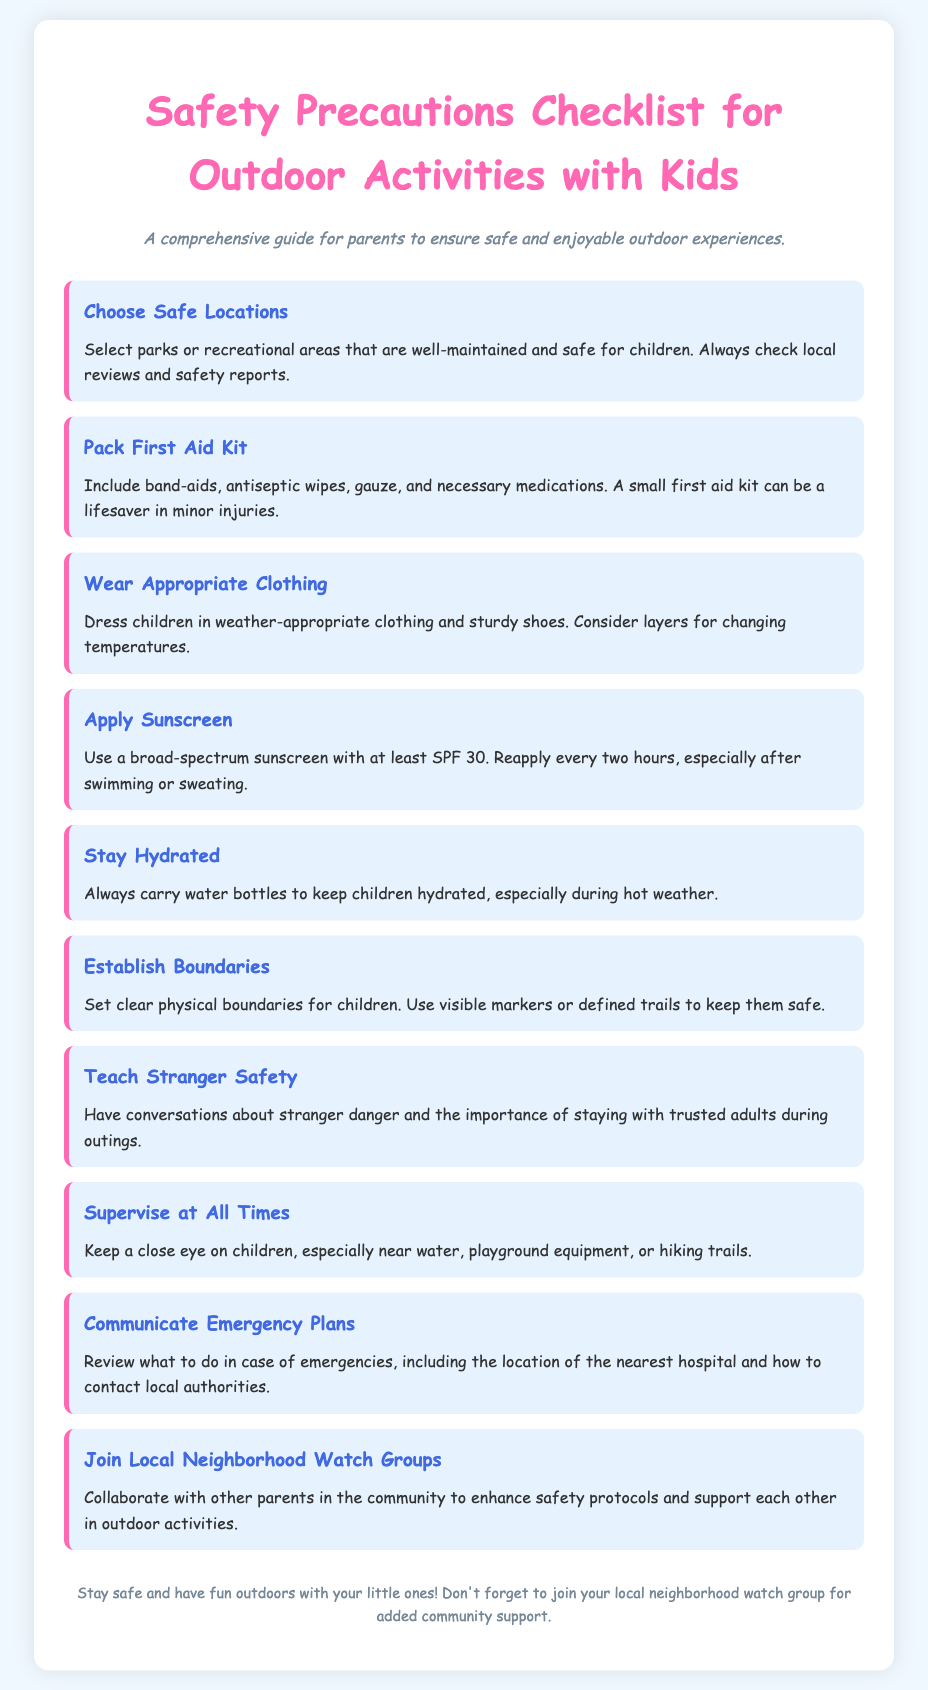What are the suggested safe locations? The document suggests selecting parks or recreational areas that are well-maintained and safe for children.
Answer: parks or recreational areas What should be included in a first aid kit? The first aid kit should include band-aids, antiseptic wipes, gauze, and necessary medications.
Answer: band-aids, antiseptic wipes, gauze, medications What should children wear for outdoor activities? Children should wear weather-appropriate clothing and sturdy shoes.
Answer: weather-appropriate clothing and sturdy shoes What SPF is recommended for sunscreen? A broad-spectrum sunscreen with at least SPF 30 is recommended.
Answer: SPF 30 What is a key reason to stay hydrated? Staying hydrated is especially important during hot weather.
Answer: hot weather What is the purpose of establishing boundaries? Establishing boundaries is to set clear physical limits for children to ensure their safety.
Answer: ensure safety How often should sunscreen be reapplied? Sunscreen should be reapplied every two hours.
Answer: every two hours What do parents need to communicate about emergencies? Parents should review what to do in case of emergencies, including the nearest hospital location and how to contact local authorities.
Answer: nearest hospital location What community involvement is suggested for parents? Parents are encouraged to join local neighborhood watch groups.
Answer: local neighborhood watch groups 